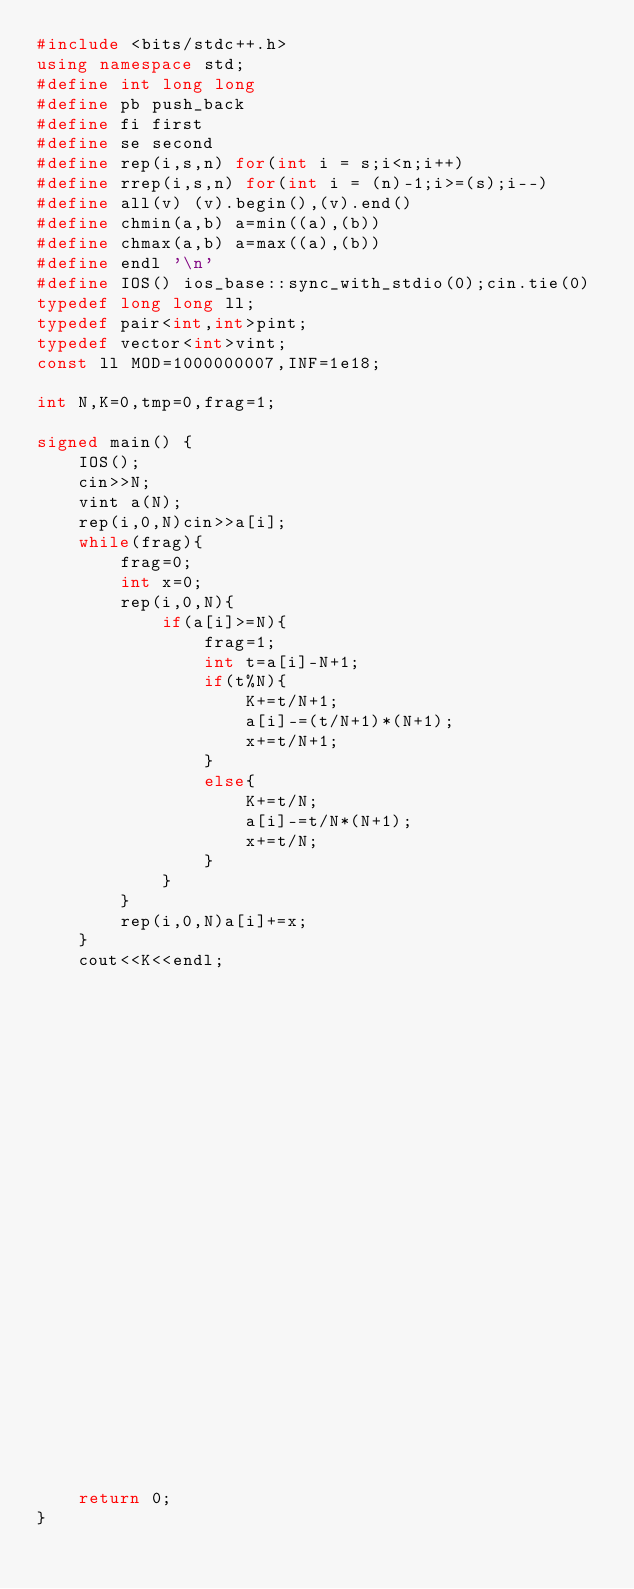Convert code to text. <code><loc_0><loc_0><loc_500><loc_500><_C++_>#include <bits/stdc++.h>
using namespace std;
#define int long long
#define pb push_back
#define fi first
#define se second
#define rep(i,s,n) for(int i = s;i<n;i++)
#define rrep(i,s,n) for(int i = (n)-1;i>=(s);i--)
#define all(v) (v).begin(),(v).end()
#define chmin(a,b) a=min((a),(b))
#define chmax(a,b) a=max((a),(b))
#define endl '\n'
#define IOS() ios_base::sync_with_stdio(0);cin.tie(0)
typedef long long ll;
typedef pair<int,int>pint;
typedef vector<int>vint;
const ll MOD=1000000007,INF=1e18;
 
int N,K=0,tmp=0,frag=1;

signed main() {
    IOS();
    cin>>N;
    vint a(N);
    rep(i,0,N)cin>>a[i];
    while(frag){
        frag=0;
        int x=0;
        rep(i,0,N){
            if(a[i]>=N){
                frag=1;
                int t=a[i]-N+1;
                if(t%N){
                    K+=t/N+1;
                    a[i]-=(t/N+1)*(N+1);
                    x+=t/N+1;
                }
                else{
                    K+=t/N;
                    a[i]-=t/N*(N+1);
                    x+=t/N;
                }
            }
        }
        rep(i,0,N)a[i]+=x;
    }
    cout<<K<<endl;
    
    
    
    
    
    
    
    
    
    
    
    
    
    
    
    
    
    
    
    
    
    
    
    
    
    
    return 0;
}</code> 